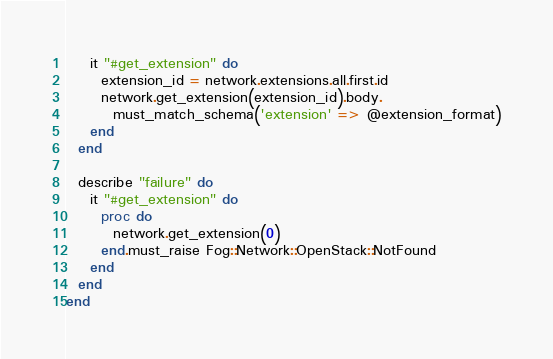<code> <loc_0><loc_0><loc_500><loc_500><_Ruby_>    it "#get_extension" do
      extension_id = network.extensions.all.first.id
      network.get_extension(extension_id).body.
        must_match_schema('extension' => @extension_format)
    end
  end

  describe "failure" do
    it "#get_extension" do
      proc do
        network.get_extension(0)
      end.must_raise Fog::Network::OpenStack::NotFound
    end
  end
end
</code> 